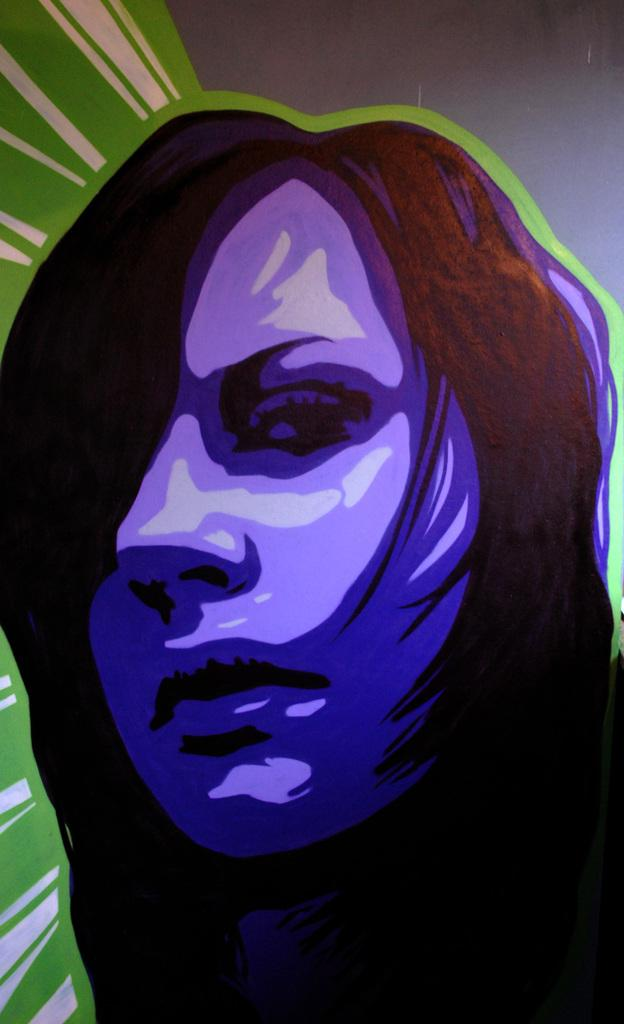What type of image is displayed in the picture? The image is an animated picture. Can you describe the main subject of the animated picture? There is an animated picture of a woman in the image. What colors are predominant in the image? The colors ash and green are present in the image. How many tickets does the writer in the image have? There is no writer or tickets present in the image; it features an animated picture of a woman. 